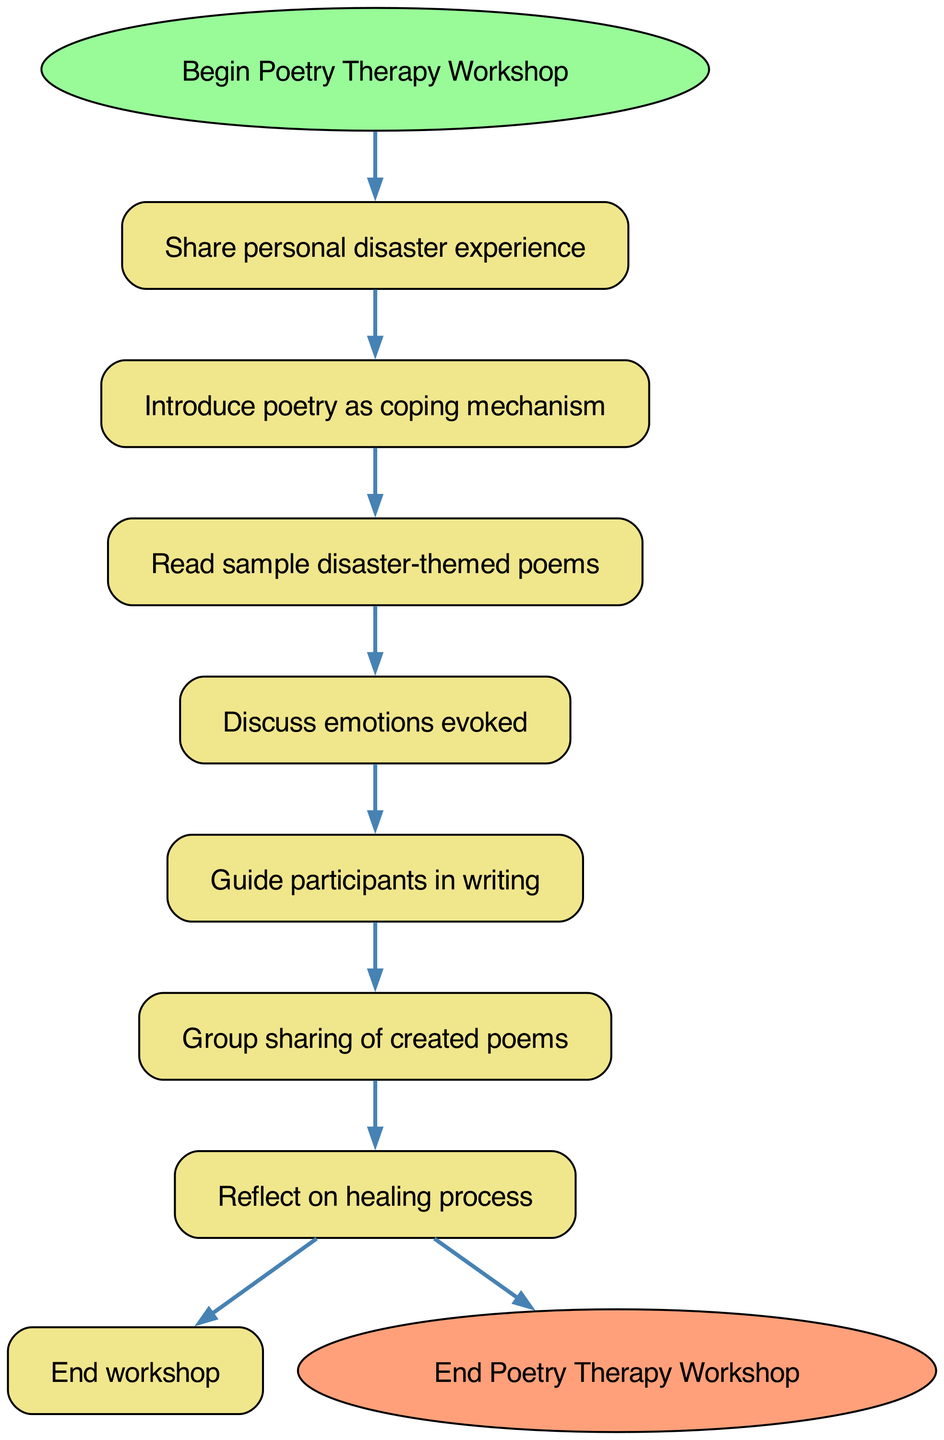What is the first step in the workshop? The first step is indicated directly from the start node, which points to "Share personal disaster experience".
Answer: Share personal disaster experience How many steps are there in the workshop? Counting the steps listed in the diagram, there are 6 main steps plus the start and end nodes, making a total of 8 nodes.
Answer: 6 What is the last step before the workshop ends? The last step shown before reaching the end node is "Reflect on healing process", following the flow of the diagram.
Answer: Reflect on healing process What is the connection between "Read sample disaster-themed poems" and "Discuss emotions evoked"? The diagram shows a direct edge from "Read sample disaster-themed poems" to "Discuss emotions evoked", indicating a sequential relationship between these two steps.
Answer: Discuss emotions evoked How does the workshop progress after sharing personal experiences? After "Share personal disaster experience", the next step in the diagram is "Introduce poetry as coping mechanism", showing the flow from the sharing to the introduction of poetry.
Answer: Introduce poetry as coping mechanism What theme is reflected in the poems read during the workshop? The theme reflected in the poems is "disaster-themed", as specified directly in the step's description within the diagram.
Answer: disaster-themed How many edges connect the steps in the workshop process? Each step connects to the next, while the total number of edges is equal to the number of steps plus the start and end connections, which results in 6 edges connecting the 6 steps in the diagram.
Answer: 6 